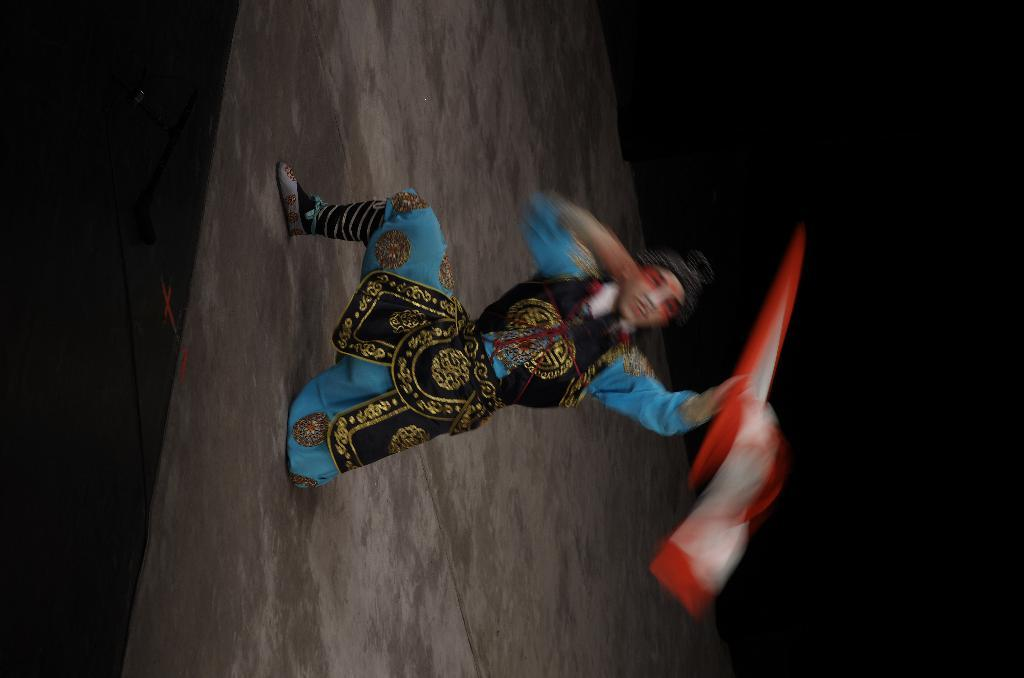What is the main subject of the image? There is a person in the image. Can you describe the person's clothing? The person is wearing a blue and brown color combination. What is the person's facial expression? The person is smiling. What is the person holding in their hand? The person is holding a cloth with one hand. How is the person positioned in the image? The person is kneeling down with one leg on the stage. What is the color of the background in the image? The background of the image is dark in color. How does the person react to the sudden ice earthquake in the image? There is no mention of ice or an earthquake in the image, so it is not possible to answer this question. 